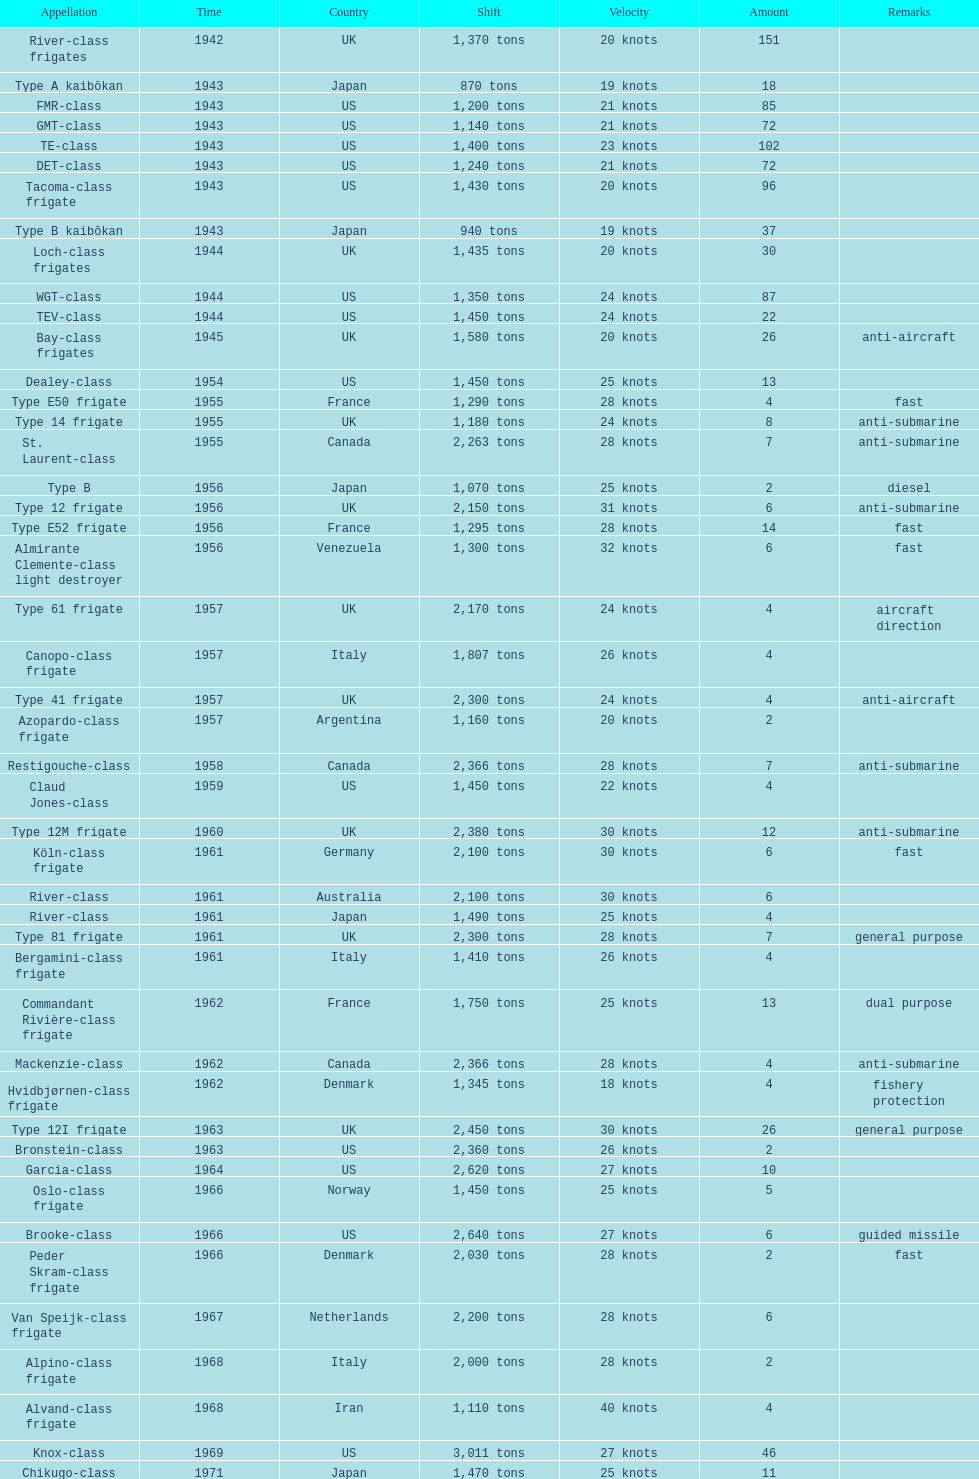What is the top speed? 40 knots. 